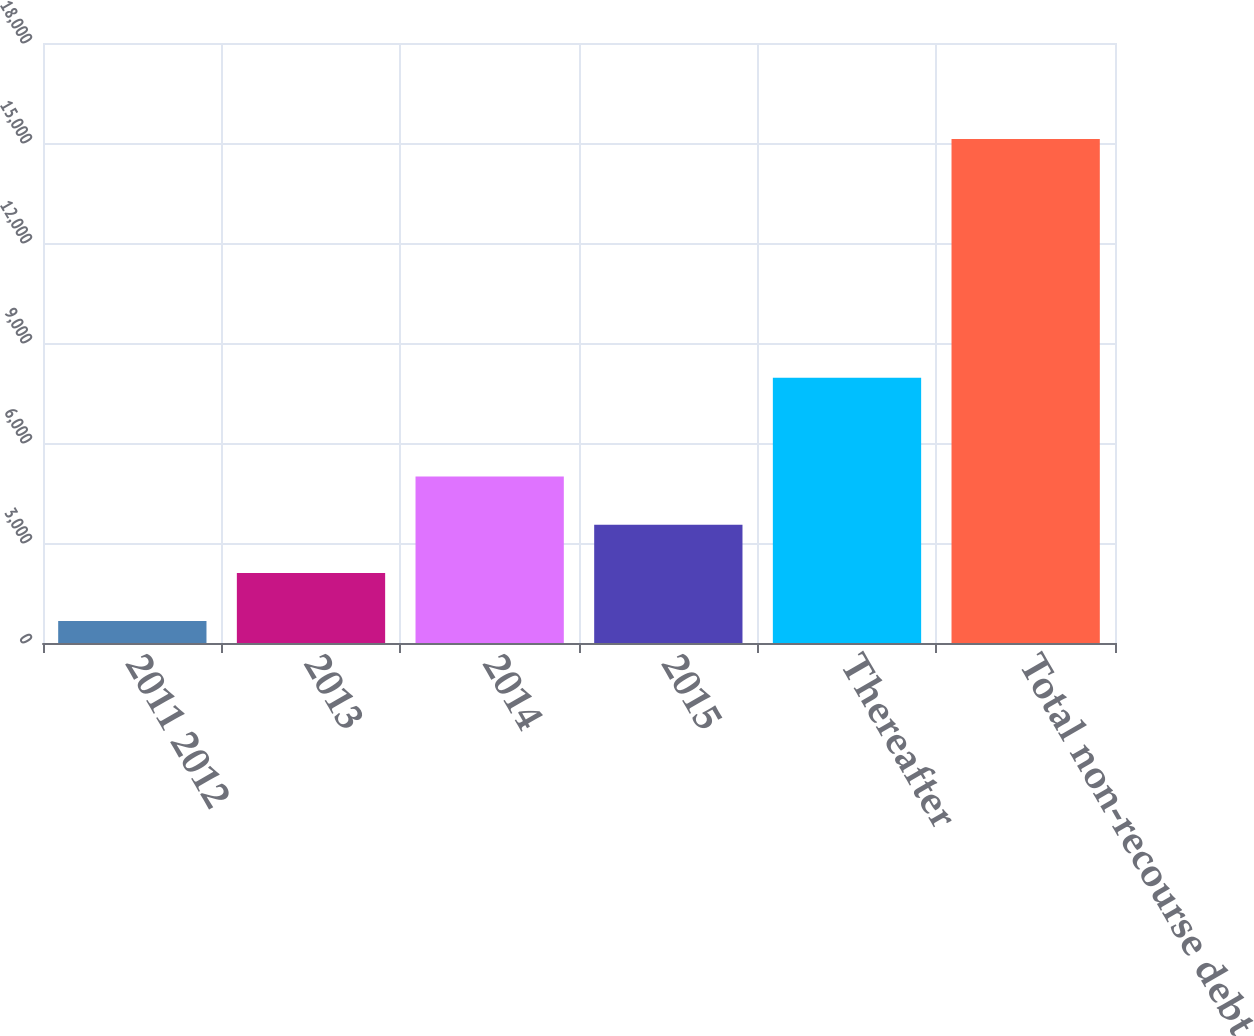Convert chart to OTSL. <chart><loc_0><loc_0><loc_500><loc_500><bar_chart><fcel>2011 2012<fcel>2013<fcel>2014<fcel>2015<fcel>Thereafter<fcel>Total non-recourse debt<nl><fcel>657<fcel>2103.4<fcel>4996.2<fcel>3549.8<fcel>7957<fcel>15121<nl></chart> 